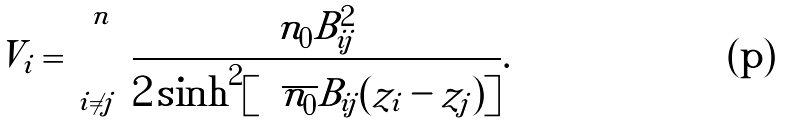<formula> <loc_0><loc_0><loc_500><loc_500>V _ { i } = \sum _ { i \ne j } ^ { n } \frac { n _ { 0 } B _ { i j } ^ { 2 } } { 2 \sinh ^ { 2 } [ \sqrt { n _ { 0 } } B _ { i j } ( z _ { i } - z _ { j } ) ] } .</formula> 